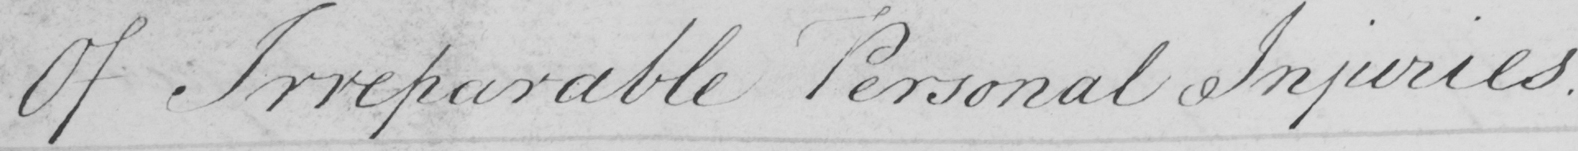Please transcribe the handwritten text in this image. Of Irreparable Personal Injuries 